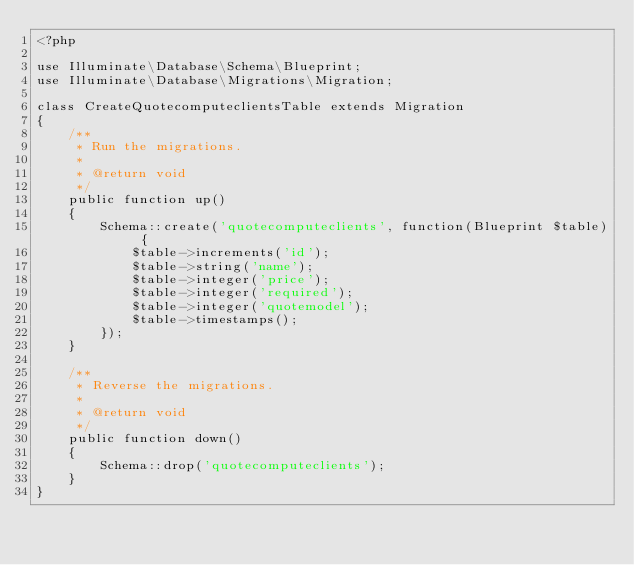Convert code to text. <code><loc_0><loc_0><loc_500><loc_500><_PHP_><?php

use Illuminate\Database\Schema\Blueprint;
use Illuminate\Database\Migrations\Migration;

class CreateQuotecomputeclientsTable extends Migration
{
    /**
     * Run the migrations.
     *
     * @return void
     */
    public function up()
    {
        Schema::create('quotecomputeclients', function(Blueprint $table) {
            $table->increments('id');
            $table->string('name');
            $table->integer('price');
            $table->integer('required');
            $table->integer('quotemodel');
            $table->timestamps();
        });
    }

    /**
     * Reverse the migrations.
     *
     * @return void
     */
    public function down()
    {
        Schema::drop('quotecomputeclients');
    }
}
</code> 